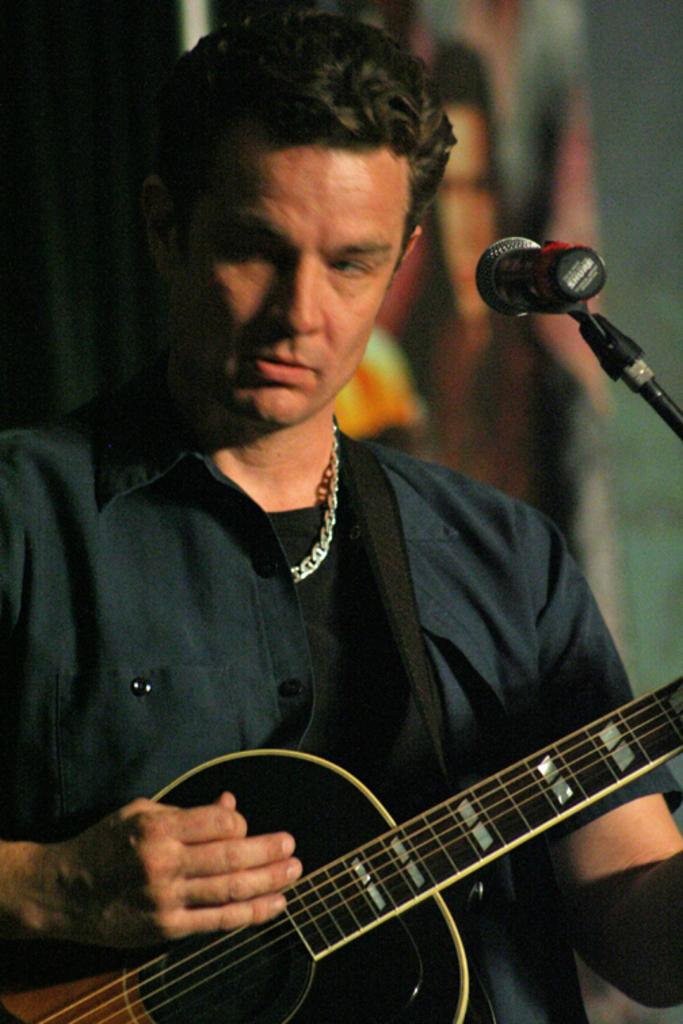What is the main subject of the image? The main subject of the image is a man. What is the man doing in the image? The man is standing in front of a microphone and playing a guitar. Can you describe any accessories the man is wearing? The man is wearing a chain. What type of leather can be seen in the scene? There is no leather present in the image. What road is the man walking on in the image? There is no road or walking depicted in the image; the man is standing in front of a microphone and playing a guitar. 